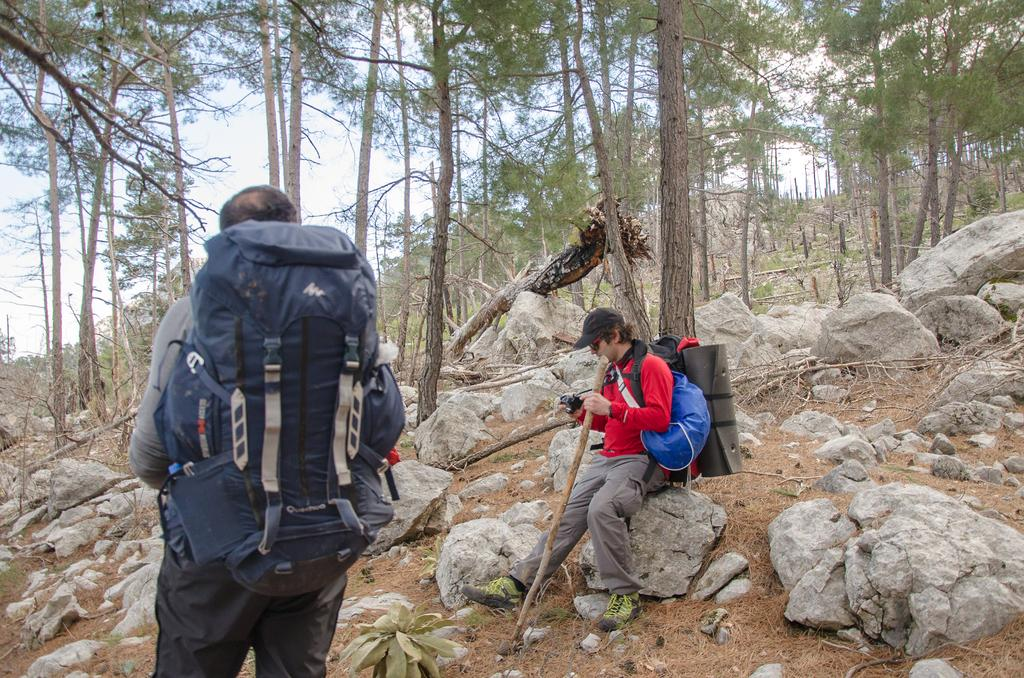How many people are present in the image? There are two people in the image. What type of natural elements can be seen in the image? There are rocks and trees in the image. What is the condition of the sky in the image? The sky is clear in the image. What type of meat is being cooked on the range in the image? There is no range or meat present in the image. 